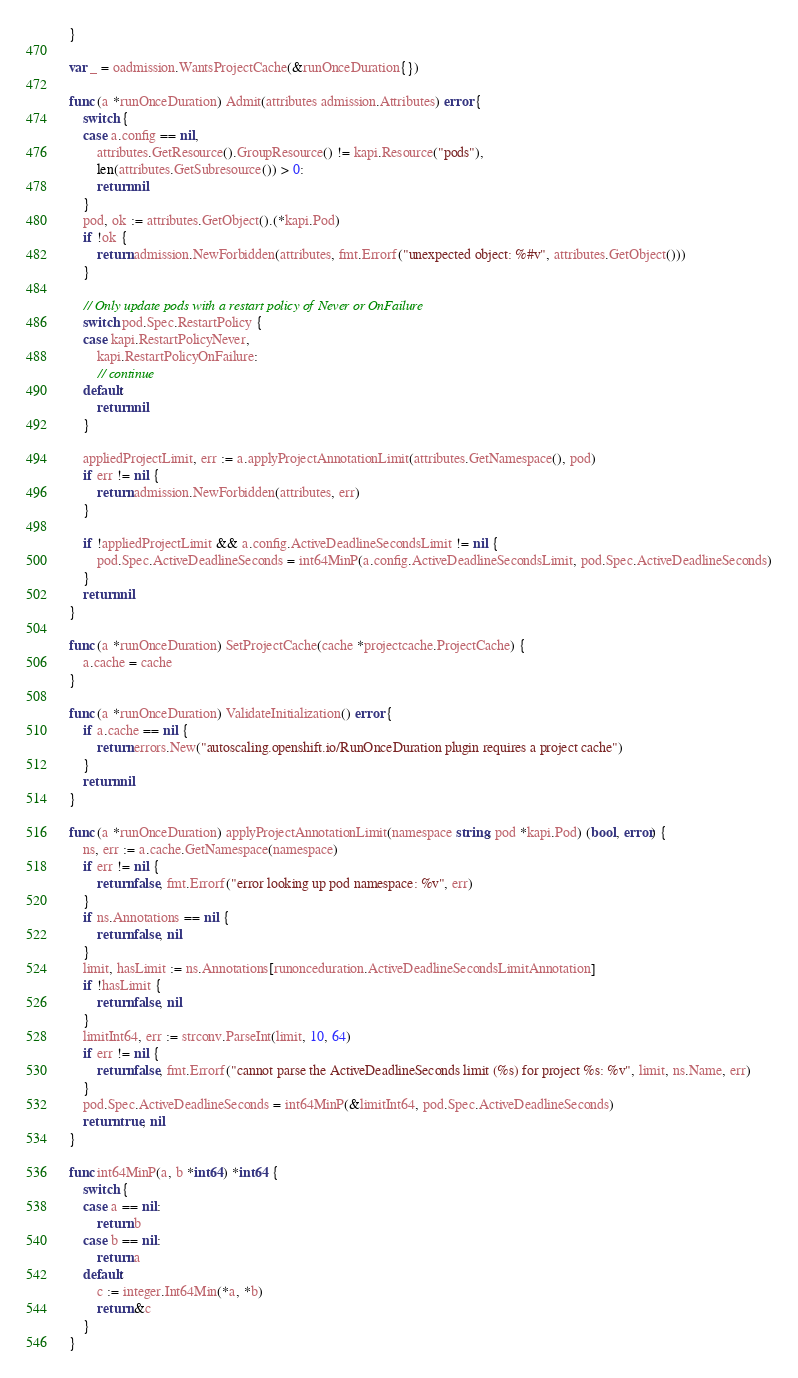<code> <loc_0><loc_0><loc_500><loc_500><_Go_>}

var _ = oadmission.WantsProjectCache(&runOnceDuration{})

func (a *runOnceDuration) Admit(attributes admission.Attributes) error {
	switch {
	case a.config == nil,
		attributes.GetResource().GroupResource() != kapi.Resource("pods"),
		len(attributes.GetSubresource()) > 0:
		return nil
	}
	pod, ok := attributes.GetObject().(*kapi.Pod)
	if !ok {
		return admission.NewForbidden(attributes, fmt.Errorf("unexpected object: %#v", attributes.GetObject()))
	}

	// Only update pods with a restart policy of Never or OnFailure
	switch pod.Spec.RestartPolicy {
	case kapi.RestartPolicyNever,
		kapi.RestartPolicyOnFailure:
		// continue
	default:
		return nil
	}

	appliedProjectLimit, err := a.applyProjectAnnotationLimit(attributes.GetNamespace(), pod)
	if err != nil {
		return admission.NewForbidden(attributes, err)
	}

	if !appliedProjectLimit && a.config.ActiveDeadlineSecondsLimit != nil {
		pod.Spec.ActiveDeadlineSeconds = int64MinP(a.config.ActiveDeadlineSecondsLimit, pod.Spec.ActiveDeadlineSeconds)
	}
	return nil
}

func (a *runOnceDuration) SetProjectCache(cache *projectcache.ProjectCache) {
	a.cache = cache
}

func (a *runOnceDuration) ValidateInitialization() error {
	if a.cache == nil {
		return errors.New("autoscaling.openshift.io/RunOnceDuration plugin requires a project cache")
	}
	return nil
}

func (a *runOnceDuration) applyProjectAnnotationLimit(namespace string, pod *kapi.Pod) (bool, error) {
	ns, err := a.cache.GetNamespace(namespace)
	if err != nil {
		return false, fmt.Errorf("error looking up pod namespace: %v", err)
	}
	if ns.Annotations == nil {
		return false, nil
	}
	limit, hasLimit := ns.Annotations[runonceduration.ActiveDeadlineSecondsLimitAnnotation]
	if !hasLimit {
		return false, nil
	}
	limitInt64, err := strconv.ParseInt(limit, 10, 64)
	if err != nil {
		return false, fmt.Errorf("cannot parse the ActiveDeadlineSeconds limit (%s) for project %s: %v", limit, ns.Name, err)
	}
	pod.Spec.ActiveDeadlineSeconds = int64MinP(&limitInt64, pod.Spec.ActiveDeadlineSeconds)
	return true, nil
}

func int64MinP(a, b *int64) *int64 {
	switch {
	case a == nil:
		return b
	case b == nil:
		return a
	default:
		c := integer.Int64Min(*a, *b)
		return &c
	}
}
</code> 